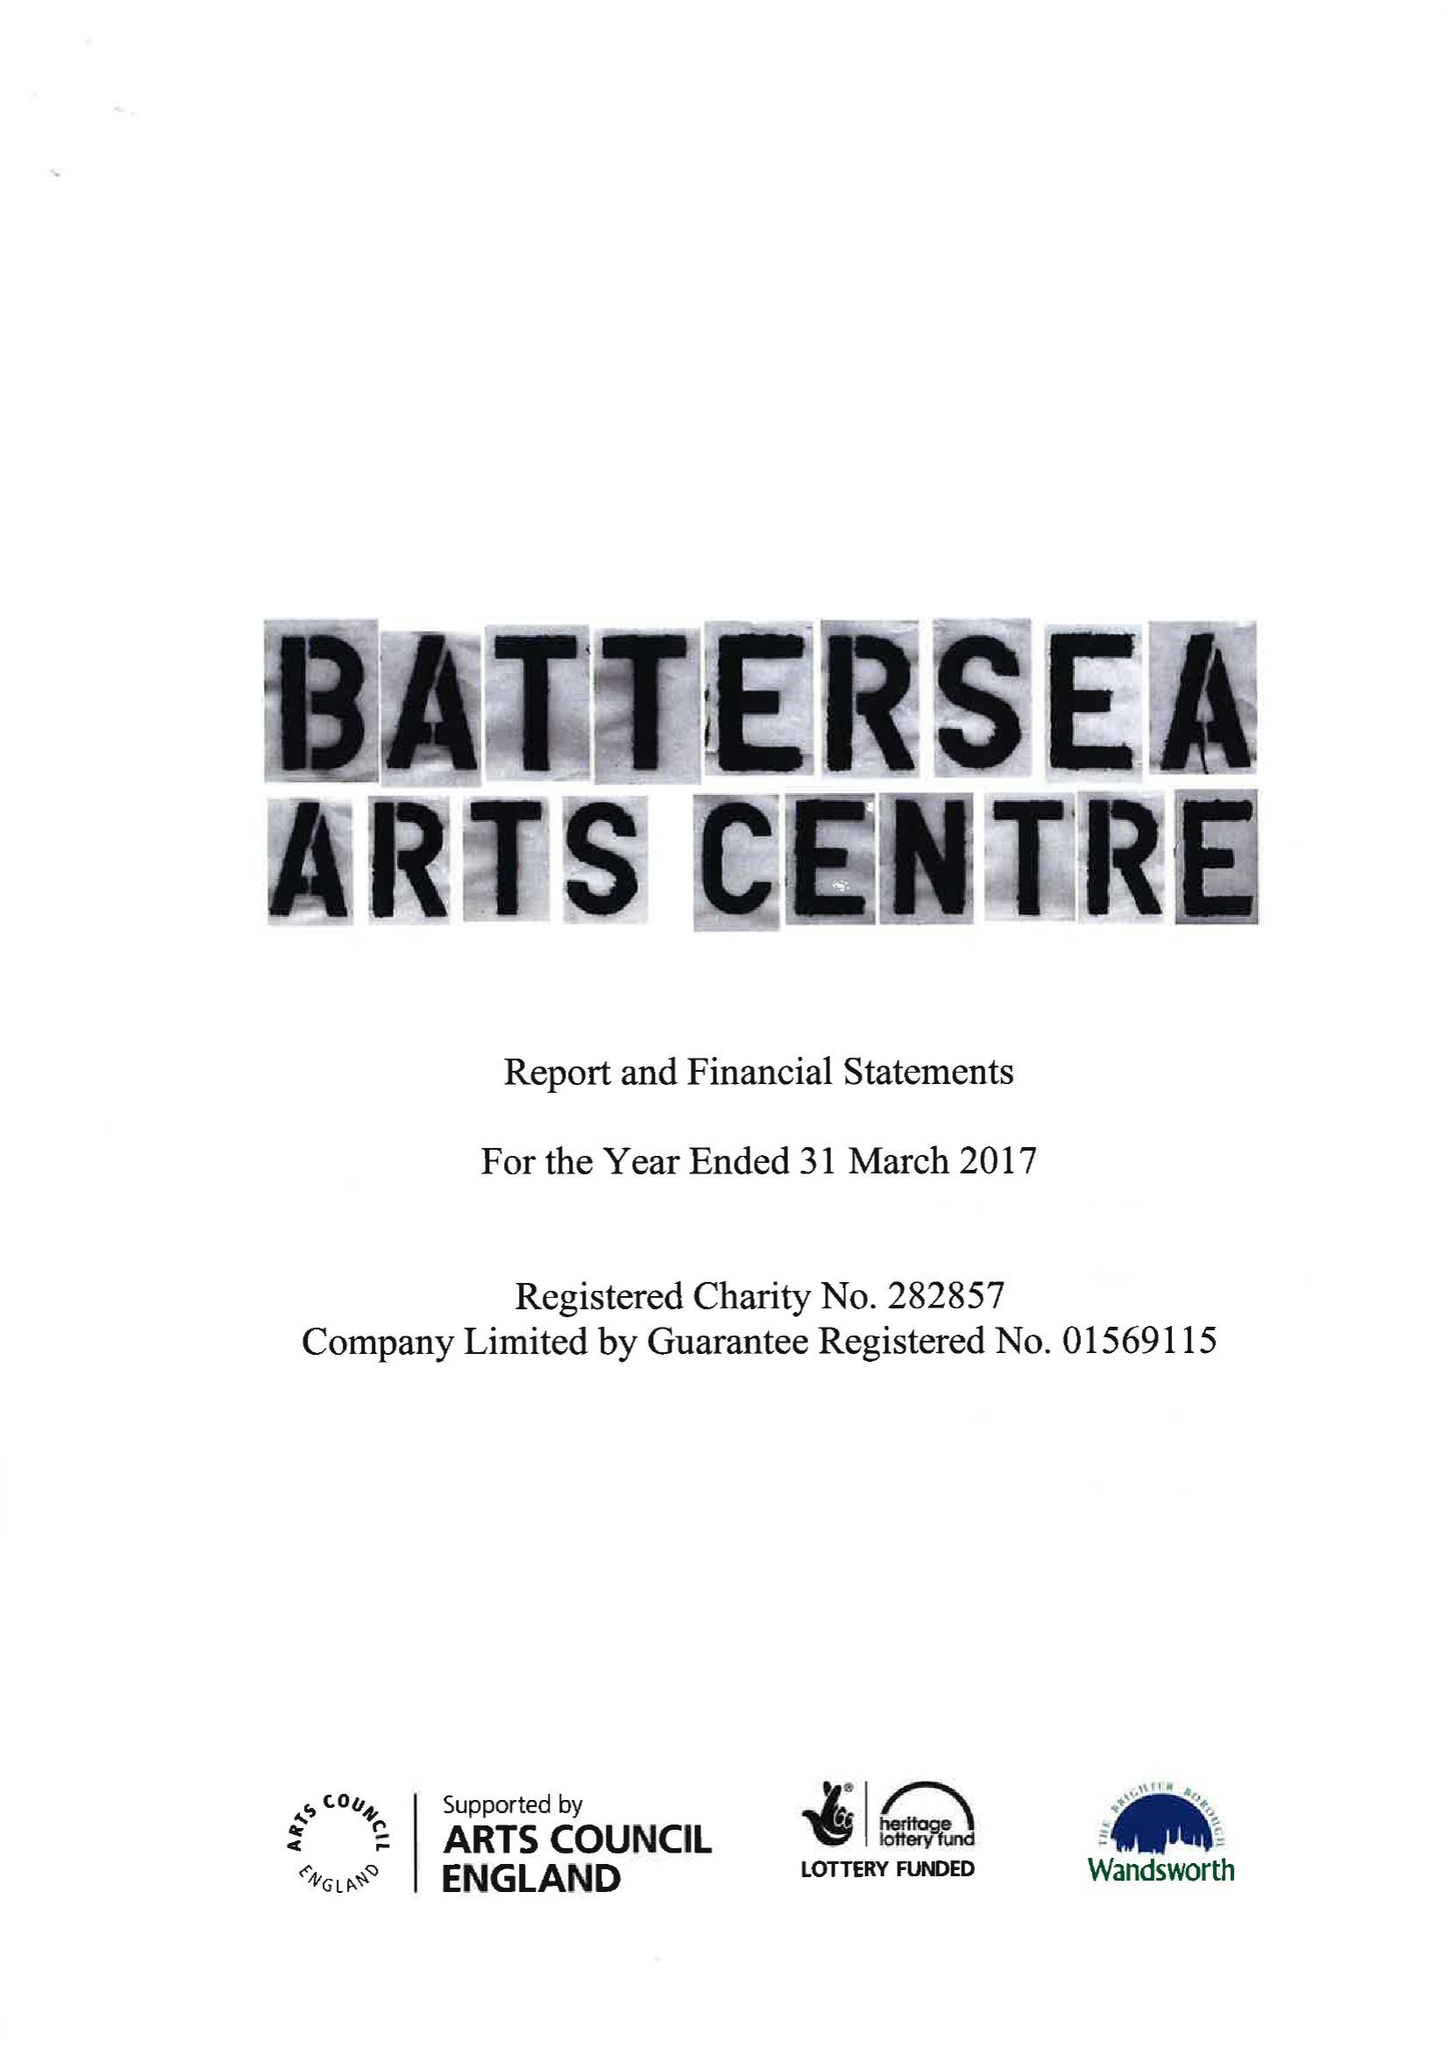What is the value for the address__post_town?
Answer the question using a single word or phrase. LONDON 